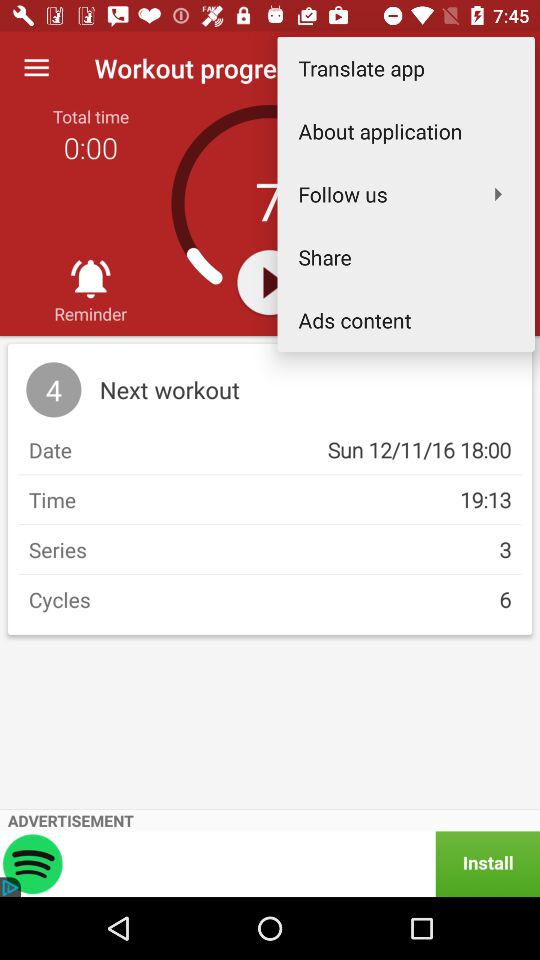What's the "Cycles" number? The "Cycles" number is 6. 